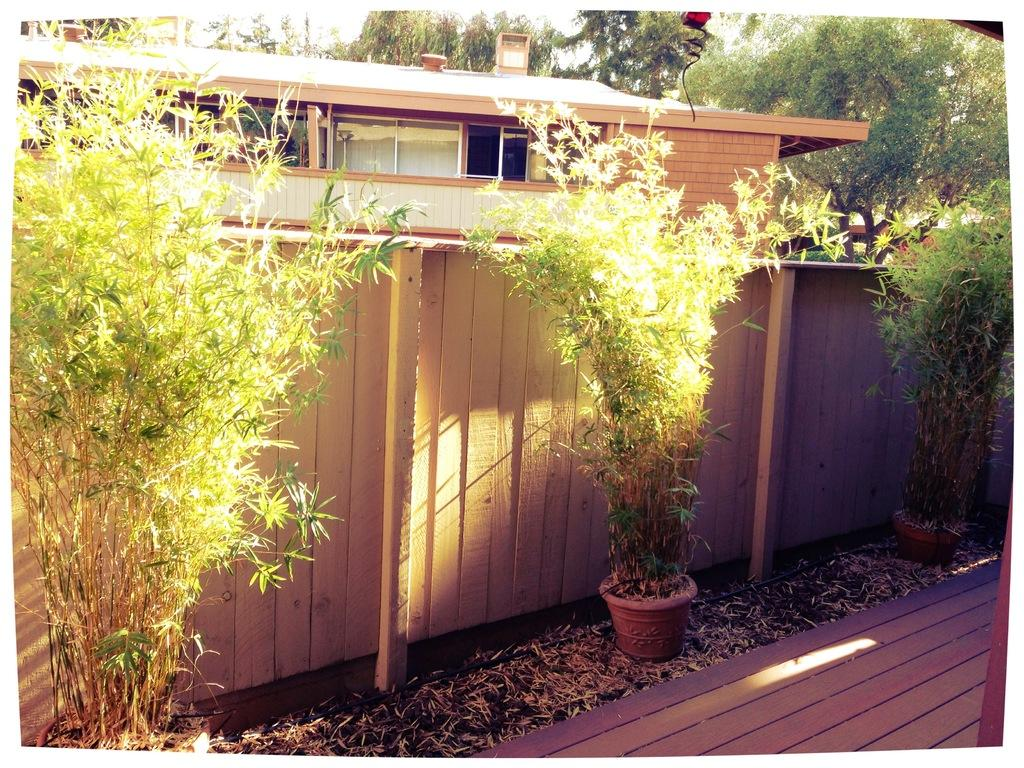What can be seen running through the image? There is a path in the image. What type of vegetation is visible in the image? There are plants visible in the image. What type of barrier is present in the image? There is fencing in the image. What can be seen in the distance in the image? There is a building and trees in the background of the image. What type of muscle is visible on the shirt of the person in the image? There is no person or shirt present in the image. Can you describe the quill used by the bird in the image? There is no bird or quill present in the image. 